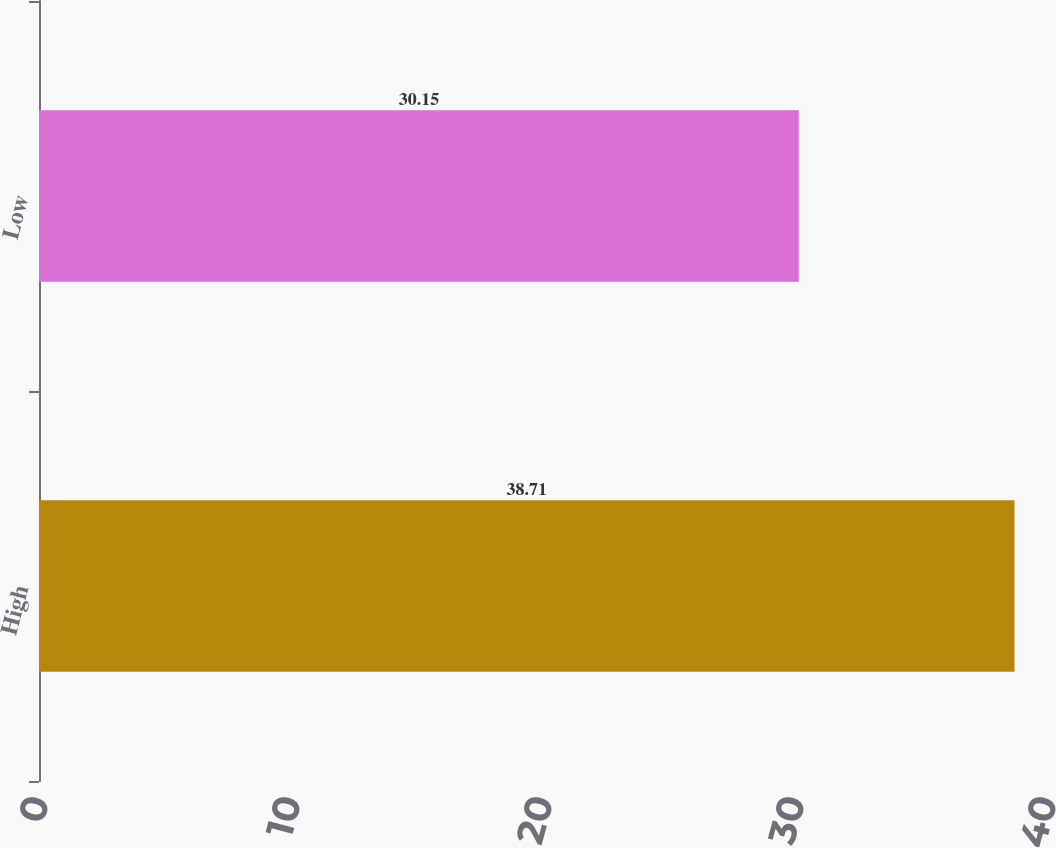Convert chart to OTSL. <chart><loc_0><loc_0><loc_500><loc_500><bar_chart><fcel>High<fcel>Low<nl><fcel>38.71<fcel>30.15<nl></chart> 